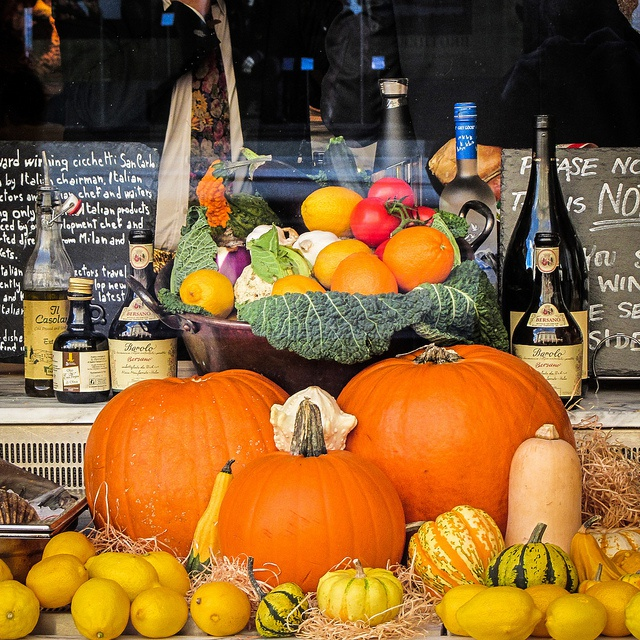Describe the objects in this image and their specific colors. I can see bottle in black, gray, and tan tones, orange in black, orange, red, and gold tones, bottle in black, khaki, tan, and gray tones, bottle in black, tan, darkgray, and gray tones, and bottle in black, khaki, and tan tones in this image. 